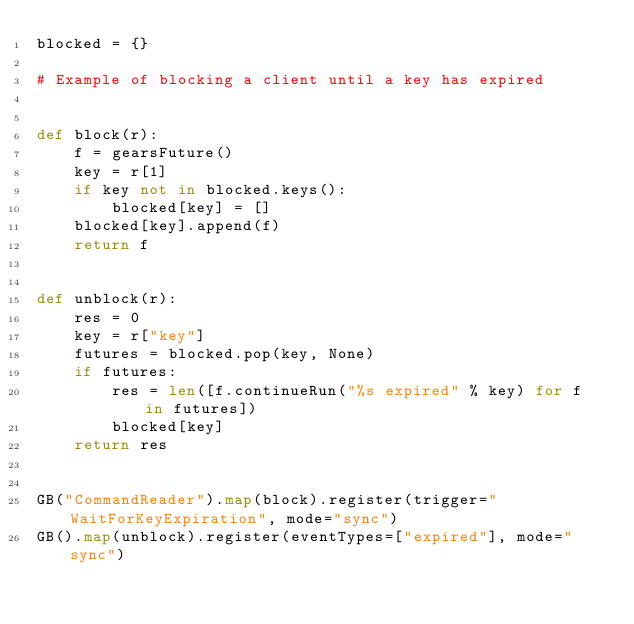<code> <loc_0><loc_0><loc_500><loc_500><_Python_>blocked = {}

# Example of blocking a client until a key has expired


def block(r):
    f = gearsFuture()
    key = r[1]
    if key not in blocked.keys():
        blocked[key] = []
    blocked[key].append(f)
    return f


def unblock(r):
    res = 0
    key = r["key"]
    futures = blocked.pop(key, None)
    if futures:
        res = len([f.continueRun("%s expired" % key) for f in futures])
        blocked[key]
    return res


GB("CommandReader").map(block).register(trigger="WaitForKeyExpiration", mode="sync")
GB().map(unblock).register(eventTypes=["expired"], mode="sync")
</code> 